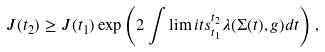Convert formula to latex. <formula><loc_0><loc_0><loc_500><loc_500>J ( t _ { 2 } ) \geq J ( t _ { 1 } ) \exp \left ( 2 \int \lim i t s _ { t _ { 1 } } ^ { t _ { 2 } } \lambda ( \Sigma ( t ) , g ) d t \right ) ,</formula> 